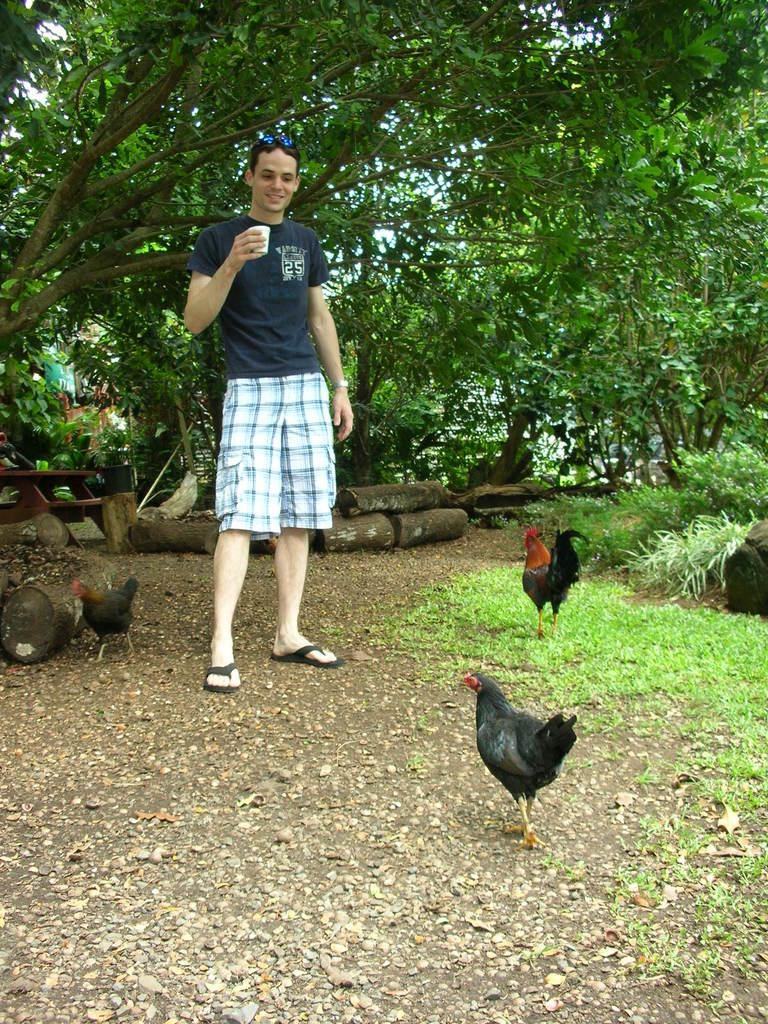What is the person in the image holding? The person is holding a glass. What is the person standing on in the image? The person is standing on a path. What type of animals can be seen on the path in the image? There are hens standing on the path in the image. What can be seen in the background of the image? Objects, grass, plants, trees, and the sky are visible in the background of the image. What type of vein is visible on the person's leg in the image? There is no visible vein on the person's leg in the image. How many levels can be seen in the image? The image does not depict any levels or multiple floors; it is a single scene. 